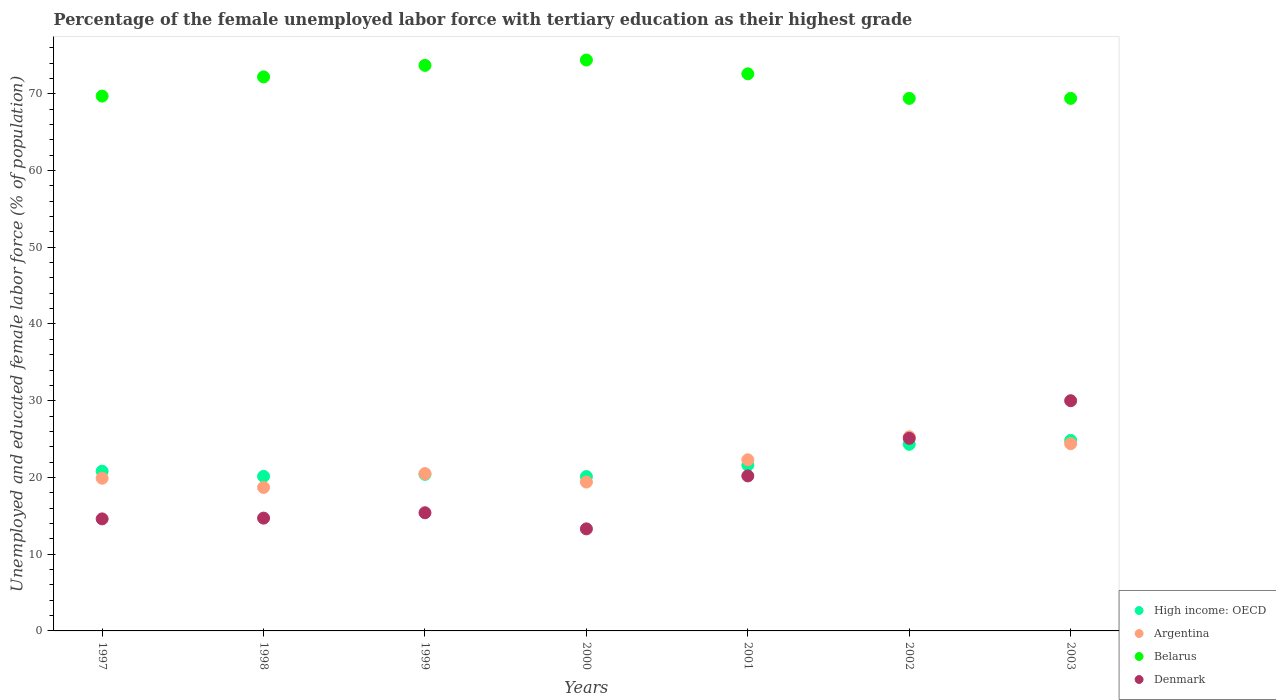How many different coloured dotlines are there?
Make the answer very short. 4. Is the number of dotlines equal to the number of legend labels?
Ensure brevity in your answer.  Yes. What is the percentage of the unemployed female labor force with tertiary education in Argentina in 2001?
Your answer should be compact. 22.3. Across all years, what is the maximum percentage of the unemployed female labor force with tertiary education in Argentina?
Offer a terse response. 25.3. Across all years, what is the minimum percentage of the unemployed female labor force with tertiary education in Argentina?
Ensure brevity in your answer.  18.7. In which year was the percentage of the unemployed female labor force with tertiary education in Belarus minimum?
Your answer should be very brief. 2002. What is the total percentage of the unemployed female labor force with tertiary education in High income: OECD in the graph?
Provide a short and direct response. 152.23. What is the difference between the percentage of the unemployed female labor force with tertiary education in Belarus in 1999 and that in 2002?
Provide a succinct answer. 4.3. What is the difference between the percentage of the unemployed female labor force with tertiary education in Argentina in 1997 and the percentage of the unemployed female labor force with tertiary education in High income: OECD in 1999?
Your answer should be compact. -0.51. What is the average percentage of the unemployed female labor force with tertiary education in Denmark per year?
Offer a terse response. 19.04. In the year 1998, what is the difference between the percentage of the unemployed female labor force with tertiary education in Belarus and percentage of the unemployed female labor force with tertiary education in Denmark?
Keep it short and to the point. 57.5. In how many years, is the percentage of the unemployed female labor force with tertiary education in High income: OECD greater than 40 %?
Your answer should be very brief. 0. What is the ratio of the percentage of the unemployed female labor force with tertiary education in Denmark in 1999 to that in 2000?
Your response must be concise. 1.16. Is the percentage of the unemployed female labor force with tertiary education in High income: OECD in 1998 less than that in 1999?
Your answer should be compact. Yes. Is the difference between the percentage of the unemployed female labor force with tertiary education in Belarus in 1997 and 2002 greater than the difference between the percentage of the unemployed female labor force with tertiary education in Denmark in 1997 and 2002?
Your answer should be very brief. Yes. What is the difference between the highest and the second highest percentage of the unemployed female labor force with tertiary education in Denmark?
Offer a terse response. 4.9. What is the difference between the highest and the lowest percentage of the unemployed female labor force with tertiary education in Belarus?
Give a very brief answer. 5. Is the sum of the percentage of the unemployed female labor force with tertiary education in Denmark in 2000 and 2003 greater than the maximum percentage of the unemployed female labor force with tertiary education in Argentina across all years?
Provide a succinct answer. Yes. Is it the case that in every year, the sum of the percentage of the unemployed female labor force with tertiary education in High income: OECD and percentage of the unemployed female labor force with tertiary education in Belarus  is greater than the sum of percentage of the unemployed female labor force with tertiary education in Argentina and percentage of the unemployed female labor force with tertiary education in Denmark?
Ensure brevity in your answer.  Yes. Is the percentage of the unemployed female labor force with tertiary education in Argentina strictly greater than the percentage of the unemployed female labor force with tertiary education in Denmark over the years?
Make the answer very short. No. Is the percentage of the unemployed female labor force with tertiary education in Belarus strictly less than the percentage of the unemployed female labor force with tertiary education in Denmark over the years?
Give a very brief answer. No. How many dotlines are there?
Provide a short and direct response. 4. How many years are there in the graph?
Give a very brief answer. 7. Does the graph contain grids?
Keep it short and to the point. No. Where does the legend appear in the graph?
Provide a short and direct response. Bottom right. How many legend labels are there?
Offer a terse response. 4. How are the legend labels stacked?
Make the answer very short. Vertical. What is the title of the graph?
Your answer should be compact. Percentage of the female unemployed labor force with tertiary education as their highest grade. What is the label or title of the X-axis?
Provide a short and direct response. Years. What is the label or title of the Y-axis?
Your response must be concise. Unemployed and educated female labor force (% of population). What is the Unemployed and educated female labor force (% of population) of High income: OECD in 1997?
Provide a short and direct response. 20.81. What is the Unemployed and educated female labor force (% of population) in Argentina in 1997?
Offer a terse response. 19.9. What is the Unemployed and educated female labor force (% of population) in Belarus in 1997?
Ensure brevity in your answer.  69.7. What is the Unemployed and educated female labor force (% of population) of Denmark in 1997?
Provide a short and direct response. 14.6. What is the Unemployed and educated female labor force (% of population) in High income: OECD in 1998?
Your answer should be compact. 20.14. What is the Unemployed and educated female labor force (% of population) in Argentina in 1998?
Give a very brief answer. 18.7. What is the Unemployed and educated female labor force (% of population) of Belarus in 1998?
Offer a very short reply. 72.2. What is the Unemployed and educated female labor force (% of population) in Denmark in 1998?
Ensure brevity in your answer.  14.7. What is the Unemployed and educated female labor force (% of population) in High income: OECD in 1999?
Offer a very short reply. 20.41. What is the Unemployed and educated female labor force (% of population) of Belarus in 1999?
Offer a terse response. 73.7. What is the Unemployed and educated female labor force (% of population) in Denmark in 1999?
Your answer should be compact. 15.4. What is the Unemployed and educated female labor force (% of population) in High income: OECD in 2000?
Offer a terse response. 20.12. What is the Unemployed and educated female labor force (% of population) of Argentina in 2000?
Provide a succinct answer. 19.4. What is the Unemployed and educated female labor force (% of population) in Belarus in 2000?
Offer a terse response. 74.4. What is the Unemployed and educated female labor force (% of population) of Denmark in 2000?
Provide a succinct answer. 13.3. What is the Unemployed and educated female labor force (% of population) in High income: OECD in 2001?
Provide a short and direct response. 21.6. What is the Unemployed and educated female labor force (% of population) in Argentina in 2001?
Provide a short and direct response. 22.3. What is the Unemployed and educated female labor force (% of population) in Belarus in 2001?
Give a very brief answer. 72.6. What is the Unemployed and educated female labor force (% of population) of Denmark in 2001?
Offer a terse response. 20.2. What is the Unemployed and educated female labor force (% of population) of High income: OECD in 2002?
Provide a short and direct response. 24.32. What is the Unemployed and educated female labor force (% of population) in Argentina in 2002?
Provide a short and direct response. 25.3. What is the Unemployed and educated female labor force (% of population) in Belarus in 2002?
Ensure brevity in your answer.  69.4. What is the Unemployed and educated female labor force (% of population) of Denmark in 2002?
Your answer should be very brief. 25.1. What is the Unemployed and educated female labor force (% of population) in High income: OECD in 2003?
Offer a very short reply. 24.83. What is the Unemployed and educated female labor force (% of population) of Argentina in 2003?
Ensure brevity in your answer.  24.4. What is the Unemployed and educated female labor force (% of population) of Belarus in 2003?
Make the answer very short. 69.4. What is the Unemployed and educated female labor force (% of population) in Denmark in 2003?
Provide a short and direct response. 30. Across all years, what is the maximum Unemployed and educated female labor force (% of population) in High income: OECD?
Your answer should be very brief. 24.83. Across all years, what is the maximum Unemployed and educated female labor force (% of population) in Argentina?
Offer a terse response. 25.3. Across all years, what is the maximum Unemployed and educated female labor force (% of population) of Belarus?
Make the answer very short. 74.4. Across all years, what is the maximum Unemployed and educated female labor force (% of population) of Denmark?
Offer a terse response. 30. Across all years, what is the minimum Unemployed and educated female labor force (% of population) in High income: OECD?
Your response must be concise. 20.12. Across all years, what is the minimum Unemployed and educated female labor force (% of population) in Argentina?
Your answer should be very brief. 18.7. Across all years, what is the minimum Unemployed and educated female labor force (% of population) in Belarus?
Provide a succinct answer. 69.4. Across all years, what is the minimum Unemployed and educated female labor force (% of population) in Denmark?
Your answer should be very brief. 13.3. What is the total Unemployed and educated female labor force (% of population) in High income: OECD in the graph?
Keep it short and to the point. 152.23. What is the total Unemployed and educated female labor force (% of population) in Argentina in the graph?
Make the answer very short. 150.5. What is the total Unemployed and educated female labor force (% of population) of Belarus in the graph?
Ensure brevity in your answer.  501.4. What is the total Unemployed and educated female labor force (% of population) of Denmark in the graph?
Make the answer very short. 133.3. What is the difference between the Unemployed and educated female labor force (% of population) in High income: OECD in 1997 and that in 1998?
Keep it short and to the point. 0.67. What is the difference between the Unemployed and educated female labor force (% of population) of Argentina in 1997 and that in 1998?
Offer a very short reply. 1.2. What is the difference between the Unemployed and educated female labor force (% of population) of High income: OECD in 1997 and that in 1999?
Offer a terse response. 0.4. What is the difference between the Unemployed and educated female labor force (% of population) in Argentina in 1997 and that in 1999?
Your response must be concise. -0.6. What is the difference between the Unemployed and educated female labor force (% of population) of Belarus in 1997 and that in 1999?
Make the answer very short. -4. What is the difference between the Unemployed and educated female labor force (% of population) in Denmark in 1997 and that in 1999?
Provide a succinct answer. -0.8. What is the difference between the Unemployed and educated female labor force (% of population) in High income: OECD in 1997 and that in 2000?
Keep it short and to the point. 0.7. What is the difference between the Unemployed and educated female labor force (% of population) in High income: OECD in 1997 and that in 2001?
Provide a short and direct response. -0.79. What is the difference between the Unemployed and educated female labor force (% of population) in High income: OECD in 1997 and that in 2002?
Make the answer very short. -3.51. What is the difference between the Unemployed and educated female labor force (% of population) of Argentina in 1997 and that in 2002?
Keep it short and to the point. -5.4. What is the difference between the Unemployed and educated female labor force (% of population) in High income: OECD in 1997 and that in 2003?
Offer a very short reply. -4.02. What is the difference between the Unemployed and educated female labor force (% of population) in Argentina in 1997 and that in 2003?
Provide a short and direct response. -4.5. What is the difference between the Unemployed and educated female labor force (% of population) in Belarus in 1997 and that in 2003?
Keep it short and to the point. 0.3. What is the difference between the Unemployed and educated female labor force (% of population) of Denmark in 1997 and that in 2003?
Keep it short and to the point. -15.4. What is the difference between the Unemployed and educated female labor force (% of population) of High income: OECD in 1998 and that in 1999?
Ensure brevity in your answer.  -0.27. What is the difference between the Unemployed and educated female labor force (% of population) in Argentina in 1998 and that in 1999?
Make the answer very short. -1.8. What is the difference between the Unemployed and educated female labor force (% of population) in High income: OECD in 1998 and that in 2000?
Your response must be concise. 0.03. What is the difference between the Unemployed and educated female labor force (% of population) of Argentina in 1998 and that in 2000?
Your response must be concise. -0.7. What is the difference between the Unemployed and educated female labor force (% of population) of Denmark in 1998 and that in 2000?
Provide a short and direct response. 1.4. What is the difference between the Unemployed and educated female labor force (% of population) of High income: OECD in 1998 and that in 2001?
Make the answer very short. -1.46. What is the difference between the Unemployed and educated female labor force (% of population) of Argentina in 1998 and that in 2001?
Offer a very short reply. -3.6. What is the difference between the Unemployed and educated female labor force (% of population) in Belarus in 1998 and that in 2001?
Your answer should be very brief. -0.4. What is the difference between the Unemployed and educated female labor force (% of population) in Denmark in 1998 and that in 2001?
Make the answer very short. -5.5. What is the difference between the Unemployed and educated female labor force (% of population) of High income: OECD in 1998 and that in 2002?
Offer a terse response. -4.17. What is the difference between the Unemployed and educated female labor force (% of population) in Argentina in 1998 and that in 2002?
Keep it short and to the point. -6.6. What is the difference between the Unemployed and educated female labor force (% of population) in Belarus in 1998 and that in 2002?
Offer a very short reply. 2.8. What is the difference between the Unemployed and educated female labor force (% of population) of Denmark in 1998 and that in 2002?
Your answer should be very brief. -10.4. What is the difference between the Unemployed and educated female labor force (% of population) in High income: OECD in 1998 and that in 2003?
Your answer should be compact. -4.69. What is the difference between the Unemployed and educated female labor force (% of population) of Denmark in 1998 and that in 2003?
Give a very brief answer. -15.3. What is the difference between the Unemployed and educated female labor force (% of population) of High income: OECD in 1999 and that in 2000?
Your answer should be compact. 0.29. What is the difference between the Unemployed and educated female labor force (% of population) in Belarus in 1999 and that in 2000?
Offer a terse response. -0.7. What is the difference between the Unemployed and educated female labor force (% of population) of High income: OECD in 1999 and that in 2001?
Provide a short and direct response. -1.19. What is the difference between the Unemployed and educated female labor force (% of population) in Argentina in 1999 and that in 2001?
Offer a very short reply. -1.8. What is the difference between the Unemployed and educated female labor force (% of population) in Belarus in 1999 and that in 2001?
Your answer should be very brief. 1.1. What is the difference between the Unemployed and educated female labor force (% of population) in High income: OECD in 1999 and that in 2002?
Provide a succinct answer. -3.91. What is the difference between the Unemployed and educated female labor force (% of population) of Belarus in 1999 and that in 2002?
Ensure brevity in your answer.  4.3. What is the difference between the Unemployed and educated female labor force (% of population) in High income: OECD in 1999 and that in 2003?
Make the answer very short. -4.42. What is the difference between the Unemployed and educated female labor force (% of population) of Denmark in 1999 and that in 2003?
Provide a short and direct response. -14.6. What is the difference between the Unemployed and educated female labor force (% of population) of High income: OECD in 2000 and that in 2001?
Make the answer very short. -1.48. What is the difference between the Unemployed and educated female labor force (% of population) of Belarus in 2000 and that in 2001?
Provide a short and direct response. 1.8. What is the difference between the Unemployed and educated female labor force (% of population) of High income: OECD in 2000 and that in 2002?
Offer a very short reply. -4.2. What is the difference between the Unemployed and educated female labor force (% of population) in Denmark in 2000 and that in 2002?
Make the answer very short. -11.8. What is the difference between the Unemployed and educated female labor force (% of population) of High income: OECD in 2000 and that in 2003?
Provide a short and direct response. -4.71. What is the difference between the Unemployed and educated female labor force (% of population) of Denmark in 2000 and that in 2003?
Ensure brevity in your answer.  -16.7. What is the difference between the Unemployed and educated female labor force (% of population) in High income: OECD in 2001 and that in 2002?
Make the answer very short. -2.72. What is the difference between the Unemployed and educated female labor force (% of population) in High income: OECD in 2001 and that in 2003?
Provide a short and direct response. -3.23. What is the difference between the Unemployed and educated female labor force (% of population) in Argentina in 2001 and that in 2003?
Make the answer very short. -2.1. What is the difference between the Unemployed and educated female labor force (% of population) in Belarus in 2001 and that in 2003?
Your answer should be very brief. 3.2. What is the difference between the Unemployed and educated female labor force (% of population) of Denmark in 2001 and that in 2003?
Keep it short and to the point. -9.8. What is the difference between the Unemployed and educated female labor force (% of population) in High income: OECD in 2002 and that in 2003?
Ensure brevity in your answer.  -0.51. What is the difference between the Unemployed and educated female labor force (% of population) in Belarus in 2002 and that in 2003?
Give a very brief answer. 0. What is the difference between the Unemployed and educated female labor force (% of population) in High income: OECD in 1997 and the Unemployed and educated female labor force (% of population) in Argentina in 1998?
Your response must be concise. 2.11. What is the difference between the Unemployed and educated female labor force (% of population) of High income: OECD in 1997 and the Unemployed and educated female labor force (% of population) of Belarus in 1998?
Provide a succinct answer. -51.39. What is the difference between the Unemployed and educated female labor force (% of population) in High income: OECD in 1997 and the Unemployed and educated female labor force (% of population) in Denmark in 1998?
Provide a succinct answer. 6.11. What is the difference between the Unemployed and educated female labor force (% of population) of Argentina in 1997 and the Unemployed and educated female labor force (% of population) of Belarus in 1998?
Keep it short and to the point. -52.3. What is the difference between the Unemployed and educated female labor force (% of population) of Argentina in 1997 and the Unemployed and educated female labor force (% of population) of Denmark in 1998?
Ensure brevity in your answer.  5.2. What is the difference between the Unemployed and educated female labor force (% of population) of Belarus in 1997 and the Unemployed and educated female labor force (% of population) of Denmark in 1998?
Provide a short and direct response. 55. What is the difference between the Unemployed and educated female labor force (% of population) of High income: OECD in 1997 and the Unemployed and educated female labor force (% of population) of Argentina in 1999?
Make the answer very short. 0.31. What is the difference between the Unemployed and educated female labor force (% of population) in High income: OECD in 1997 and the Unemployed and educated female labor force (% of population) in Belarus in 1999?
Keep it short and to the point. -52.89. What is the difference between the Unemployed and educated female labor force (% of population) in High income: OECD in 1997 and the Unemployed and educated female labor force (% of population) in Denmark in 1999?
Keep it short and to the point. 5.41. What is the difference between the Unemployed and educated female labor force (% of population) in Argentina in 1997 and the Unemployed and educated female labor force (% of population) in Belarus in 1999?
Your answer should be very brief. -53.8. What is the difference between the Unemployed and educated female labor force (% of population) in Argentina in 1997 and the Unemployed and educated female labor force (% of population) in Denmark in 1999?
Offer a terse response. 4.5. What is the difference between the Unemployed and educated female labor force (% of population) of Belarus in 1997 and the Unemployed and educated female labor force (% of population) of Denmark in 1999?
Make the answer very short. 54.3. What is the difference between the Unemployed and educated female labor force (% of population) in High income: OECD in 1997 and the Unemployed and educated female labor force (% of population) in Argentina in 2000?
Make the answer very short. 1.41. What is the difference between the Unemployed and educated female labor force (% of population) of High income: OECD in 1997 and the Unemployed and educated female labor force (% of population) of Belarus in 2000?
Make the answer very short. -53.59. What is the difference between the Unemployed and educated female labor force (% of population) of High income: OECD in 1997 and the Unemployed and educated female labor force (% of population) of Denmark in 2000?
Keep it short and to the point. 7.51. What is the difference between the Unemployed and educated female labor force (% of population) of Argentina in 1997 and the Unemployed and educated female labor force (% of population) of Belarus in 2000?
Give a very brief answer. -54.5. What is the difference between the Unemployed and educated female labor force (% of population) of Belarus in 1997 and the Unemployed and educated female labor force (% of population) of Denmark in 2000?
Provide a short and direct response. 56.4. What is the difference between the Unemployed and educated female labor force (% of population) in High income: OECD in 1997 and the Unemployed and educated female labor force (% of population) in Argentina in 2001?
Your answer should be compact. -1.49. What is the difference between the Unemployed and educated female labor force (% of population) in High income: OECD in 1997 and the Unemployed and educated female labor force (% of population) in Belarus in 2001?
Your answer should be compact. -51.79. What is the difference between the Unemployed and educated female labor force (% of population) in High income: OECD in 1997 and the Unemployed and educated female labor force (% of population) in Denmark in 2001?
Make the answer very short. 0.61. What is the difference between the Unemployed and educated female labor force (% of population) in Argentina in 1997 and the Unemployed and educated female labor force (% of population) in Belarus in 2001?
Your response must be concise. -52.7. What is the difference between the Unemployed and educated female labor force (% of population) in Argentina in 1997 and the Unemployed and educated female labor force (% of population) in Denmark in 2001?
Give a very brief answer. -0.3. What is the difference between the Unemployed and educated female labor force (% of population) of Belarus in 1997 and the Unemployed and educated female labor force (% of population) of Denmark in 2001?
Your response must be concise. 49.5. What is the difference between the Unemployed and educated female labor force (% of population) of High income: OECD in 1997 and the Unemployed and educated female labor force (% of population) of Argentina in 2002?
Give a very brief answer. -4.49. What is the difference between the Unemployed and educated female labor force (% of population) of High income: OECD in 1997 and the Unemployed and educated female labor force (% of population) of Belarus in 2002?
Your answer should be very brief. -48.59. What is the difference between the Unemployed and educated female labor force (% of population) of High income: OECD in 1997 and the Unemployed and educated female labor force (% of population) of Denmark in 2002?
Your answer should be compact. -4.29. What is the difference between the Unemployed and educated female labor force (% of population) of Argentina in 1997 and the Unemployed and educated female labor force (% of population) of Belarus in 2002?
Keep it short and to the point. -49.5. What is the difference between the Unemployed and educated female labor force (% of population) in Argentina in 1997 and the Unemployed and educated female labor force (% of population) in Denmark in 2002?
Offer a very short reply. -5.2. What is the difference between the Unemployed and educated female labor force (% of population) in Belarus in 1997 and the Unemployed and educated female labor force (% of population) in Denmark in 2002?
Make the answer very short. 44.6. What is the difference between the Unemployed and educated female labor force (% of population) of High income: OECD in 1997 and the Unemployed and educated female labor force (% of population) of Argentina in 2003?
Ensure brevity in your answer.  -3.59. What is the difference between the Unemployed and educated female labor force (% of population) in High income: OECD in 1997 and the Unemployed and educated female labor force (% of population) in Belarus in 2003?
Give a very brief answer. -48.59. What is the difference between the Unemployed and educated female labor force (% of population) of High income: OECD in 1997 and the Unemployed and educated female labor force (% of population) of Denmark in 2003?
Give a very brief answer. -9.19. What is the difference between the Unemployed and educated female labor force (% of population) of Argentina in 1997 and the Unemployed and educated female labor force (% of population) of Belarus in 2003?
Provide a succinct answer. -49.5. What is the difference between the Unemployed and educated female labor force (% of population) of Argentina in 1997 and the Unemployed and educated female labor force (% of population) of Denmark in 2003?
Offer a terse response. -10.1. What is the difference between the Unemployed and educated female labor force (% of population) in Belarus in 1997 and the Unemployed and educated female labor force (% of population) in Denmark in 2003?
Offer a terse response. 39.7. What is the difference between the Unemployed and educated female labor force (% of population) of High income: OECD in 1998 and the Unemployed and educated female labor force (% of population) of Argentina in 1999?
Provide a short and direct response. -0.36. What is the difference between the Unemployed and educated female labor force (% of population) in High income: OECD in 1998 and the Unemployed and educated female labor force (% of population) in Belarus in 1999?
Give a very brief answer. -53.56. What is the difference between the Unemployed and educated female labor force (% of population) in High income: OECD in 1998 and the Unemployed and educated female labor force (% of population) in Denmark in 1999?
Offer a very short reply. 4.74. What is the difference between the Unemployed and educated female labor force (% of population) in Argentina in 1998 and the Unemployed and educated female labor force (% of population) in Belarus in 1999?
Your answer should be compact. -55. What is the difference between the Unemployed and educated female labor force (% of population) in Belarus in 1998 and the Unemployed and educated female labor force (% of population) in Denmark in 1999?
Your answer should be compact. 56.8. What is the difference between the Unemployed and educated female labor force (% of population) of High income: OECD in 1998 and the Unemployed and educated female labor force (% of population) of Argentina in 2000?
Make the answer very short. 0.74. What is the difference between the Unemployed and educated female labor force (% of population) in High income: OECD in 1998 and the Unemployed and educated female labor force (% of population) in Belarus in 2000?
Offer a very short reply. -54.26. What is the difference between the Unemployed and educated female labor force (% of population) in High income: OECD in 1998 and the Unemployed and educated female labor force (% of population) in Denmark in 2000?
Provide a short and direct response. 6.84. What is the difference between the Unemployed and educated female labor force (% of population) in Argentina in 1998 and the Unemployed and educated female labor force (% of population) in Belarus in 2000?
Make the answer very short. -55.7. What is the difference between the Unemployed and educated female labor force (% of population) of Belarus in 1998 and the Unemployed and educated female labor force (% of population) of Denmark in 2000?
Your answer should be compact. 58.9. What is the difference between the Unemployed and educated female labor force (% of population) in High income: OECD in 1998 and the Unemployed and educated female labor force (% of population) in Argentina in 2001?
Keep it short and to the point. -2.16. What is the difference between the Unemployed and educated female labor force (% of population) of High income: OECD in 1998 and the Unemployed and educated female labor force (% of population) of Belarus in 2001?
Your answer should be compact. -52.46. What is the difference between the Unemployed and educated female labor force (% of population) of High income: OECD in 1998 and the Unemployed and educated female labor force (% of population) of Denmark in 2001?
Offer a terse response. -0.06. What is the difference between the Unemployed and educated female labor force (% of population) of Argentina in 1998 and the Unemployed and educated female labor force (% of population) of Belarus in 2001?
Ensure brevity in your answer.  -53.9. What is the difference between the Unemployed and educated female labor force (% of population) in Belarus in 1998 and the Unemployed and educated female labor force (% of population) in Denmark in 2001?
Ensure brevity in your answer.  52. What is the difference between the Unemployed and educated female labor force (% of population) in High income: OECD in 1998 and the Unemployed and educated female labor force (% of population) in Argentina in 2002?
Make the answer very short. -5.16. What is the difference between the Unemployed and educated female labor force (% of population) in High income: OECD in 1998 and the Unemployed and educated female labor force (% of population) in Belarus in 2002?
Ensure brevity in your answer.  -49.26. What is the difference between the Unemployed and educated female labor force (% of population) in High income: OECD in 1998 and the Unemployed and educated female labor force (% of population) in Denmark in 2002?
Keep it short and to the point. -4.96. What is the difference between the Unemployed and educated female labor force (% of population) of Argentina in 1998 and the Unemployed and educated female labor force (% of population) of Belarus in 2002?
Keep it short and to the point. -50.7. What is the difference between the Unemployed and educated female labor force (% of population) of Belarus in 1998 and the Unemployed and educated female labor force (% of population) of Denmark in 2002?
Offer a very short reply. 47.1. What is the difference between the Unemployed and educated female labor force (% of population) of High income: OECD in 1998 and the Unemployed and educated female labor force (% of population) of Argentina in 2003?
Your answer should be compact. -4.26. What is the difference between the Unemployed and educated female labor force (% of population) of High income: OECD in 1998 and the Unemployed and educated female labor force (% of population) of Belarus in 2003?
Give a very brief answer. -49.26. What is the difference between the Unemployed and educated female labor force (% of population) of High income: OECD in 1998 and the Unemployed and educated female labor force (% of population) of Denmark in 2003?
Ensure brevity in your answer.  -9.86. What is the difference between the Unemployed and educated female labor force (% of population) in Argentina in 1998 and the Unemployed and educated female labor force (% of population) in Belarus in 2003?
Make the answer very short. -50.7. What is the difference between the Unemployed and educated female labor force (% of population) in Argentina in 1998 and the Unemployed and educated female labor force (% of population) in Denmark in 2003?
Ensure brevity in your answer.  -11.3. What is the difference between the Unemployed and educated female labor force (% of population) in Belarus in 1998 and the Unemployed and educated female labor force (% of population) in Denmark in 2003?
Make the answer very short. 42.2. What is the difference between the Unemployed and educated female labor force (% of population) in High income: OECD in 1999 and the Unemployed and educated female labor force (% of population) in Argentina in 2000?
Provide a succinct answer. 1.01. What is the difference between the Unemployed and educated female labor force (% of population) in High income: OECD in 1999 and the Unemployed and educated female labor force (% of population) in Belarus in 2000?
Offer a very short reply. -53.99. What is the difference between the Unemployed and educated female labor force (% of population) in High income: OECD in 1999 and the Unemployed and educated female labor force (% of population) in Denmark in 2000?
Your answer should be compact. 7.11. What is the difference between the Unemployed and educated female labor force (% of population) of Argentina in 1999 and the Unemployed and educated female labor force (% of population) of Belarus in 2000?
Offer a terse response. -53.9. What is the difference between the Unemployed and educated female labor force (% of population) in Belarus in 1999 and the Unemployed and educated female labor force (% of population) in Denmark in 2000?
Keep it short and to the point. 60.4. What is the difference between the Unemployed and educated female labor force (% of population) of High income: OECD in 1999 and the Unemployed and educated female labor force (% of population) of Argentina in 2001?
Your answer should be very brief. -1.89. What is the difference between the Unemployed and educated female labor force (% of population) in High income: OECD in 1999 and the Unemployed and educated female labor force (% of population) in Belarus in 2001?
Ensure brevity in your answer.  -52.19. What is the difference between the Unemployed and educated female labor force (% of population) of High income: OECD in 1999 and the Unemployed and educated female labor force (% of population) of Denmark in 2001?
Keep it short and to the point. 0.21. What is the difference between the Unemployed and educated female labor force (% of population) in Argentina in 1999 and the Unemployed and educated female labor force (% of population) in Belarus in 2001?
Provide a short and direct response. -52.1. What is the difference between the Unemployed and educated female labor force (% of population) of Belarus in 1999 and the Unemployed and educated female labor force (% of population) of Denmark in 2001?
Your answer should be compact. 53.5. What is the difference between the Unemployed and educated female labor force (% of population) in High income: OECD in 1999 and the Unemployed and educated female labor force (% of population) in Argentina in 2002?
Ensure brevity in your answer.  -4.89. What is the difference between the Unemployed and educated female labor force (% of population) of High income: OECD in 1999 and the Unemployed and educated female labor force (% of population) of Belarus in 2002?
Your answer should be very brief. -48.99. What is the difference between the Unemployed and educated female labor force (% of population) of High income: OECD in 1999 and the Unemployed and educated female labor force (% of population) of Denmark in 2002?
Keep it short and to the point. -4.69. What is the difference between the Unemployed and educated female labor force (% of population) in Argentina in 1999 and the Unemployed and educated female labor force (% of population) in Belarus in 2002?
Ensure brevity in your answer.  -48.9. What is the difference between the Unemployed and educated female labor force (% of population) of Argentina in 1999 and the Unemployed and educated female labor force (% of population) of Denmark in 2002?
Your answer should be very brief. -4.6. What is the difference between the Unemployed and educated female labor force (% of population) in Belarus in 1999 and the Unemployed and educated female labor force (% of population) in Denmark in 2002?
Give a very brief answer. 48.6. What is the difference between the Unemployed and educated female labor force (% of population) in High income: OECD in 1999 and the Unemployed and educated female labor force (% of population) in Argentina in 2003?
Make the answer very short. -3.99. What is the difference between the Unemployed and educated female labor force (% of population) in High income: OECD in 1999 and the Unemployed and educated female labor force (% of population) in Belarus in 2003?
Offer a terse response. -48.99. What is the difference between the Unemployed and educated female labor force (% of population) in High income: OECD in 1999 and the Unemployed and educated female labor force (% of population) in Denmark in 2003?
Your answer should be very brief. -9.59. What is the difference between the Unemployed and educated female labor force (% of population) of Argentina in 1999 and the Unemployed and educated female labor force (% of population) of Belarus in 2003?
Provide a succinct answer. -48.9. What is the difference between the Unemployed and educated female labor force (% of population) of Belarus in 1999 and the Unemployed and educated female labor force (% of population) of Denmark in 2003?
Ensure brevity in your answer.  43.7. What is the difference between the Unemployed and educated female labor force (% of population) in High income: OECD in 2000 and the Unemployed and educated female labor force (% of population) in Argentina in 2001?
Ensure brevity in your answer.  -2.18. What is the difference between the Unemployed and educated female labor force (% of population) of High income: OECD in 2000 and the Unemployed and educated female labor force (% of population) of Belarus in 2001?
Offer a very short reply. -52.48. What is the difference between the Unemployed and educated female labor force (% of population) of High income: OECD in 2000 and the Unemployed and educated female labor force (% of population) of Denmark in 2001?
Give a very brief answer. -0.08. What is the difference between the Unemployed and educated female labor force (% of population) of Argentina in 2000 and the Unemployed and educated female labor force (% of population) of Belarus in 2001?
Offer a terse response. -53.2. What is the difference between the Unemployed and educated female labor force (% of population) of Argentina in 2000 and the Unemployed and educated female labor force (% of population) of Denmark in 2001?
Give a very brief answer. -0.8. What is the difference between the Unemployed and educated female labor force (% of population) of Belarus in 2000 and the Unemployed and educated female labor force (% of population) of Denmark in 2001?
Your answer should be compact. 54.2. What is the difference between the Unemployed and educated female labor force (% of population) in High income: OECD in 2000 and the Unemployed and educated female labor force (% of population) in Argentina in 2002?
Give a very brief answer. -5.18. What is the difference between the Unemployed and educated female labor force (% of population) of High income: OECD in 2000 and the Unemployed and educated female labor force (% of population) of Belarus in 2002?
Your answer should be very brief. -49.28. What is the difference between the Unemployed and educated female labor force (% of population) in High income: OECD in 2000 and the Unemployed and educated female labor force (% of population) in Denmark in 2002?
Offer a very short reply. -4.98. What is the difference between the Unemployed and educated female labor force (% of population) in Belarus in 2000 and the Unemployed and educated female labor force (% of population) in Denmark in 2002?
Your response must be concise. 49.3. What is the difference between the Unemployed and educated female labor force (% of population) of High income: OECD in 2000 and the Unemployed and educated female labor force (% of population) of Argentina in 2003?
Keep it short and to the point. -4.28. What is the difference between the Unemployed and educated female labor force (% of population) in High income: OECD in 2000 and the Unemployed and educated female labor force (% of population) in Belarus in 2003?
Keep it short and to the point. -49.28. What is the difference between the Unemployed and educated female labor force (% of population) in High income: OECD in 2000 and the Unemployed and educated female labor force (% of population) in Denmark in 2003?
Offer a terse response. -9.88. What is the difference between the Unemployed and educated female labor force (% of population) of Belarus in 2000 and the Unemployed and educated female labor force (% of population) of Denmark in 2003?
Make the answer very short. 44.4. What is the difference between the Unemployed and educated female labor force (% of population) of High income: OECD in 2001 and the Unemployed and educated female labor force (% of population) of Argentina in 2002?
Ensure brevity in your answer.  -3.7. What is the difference between the Unemployed and educated female labor force (% of population) in High income: OECD in 2001 and the Unemployed and educated female labor force (% of population) in Belarus in 2002?
Offer a terse response. -47.8. What is the difference between the Unemployed and educated female labor force (% of population) in High income: OECD in 2001 and the Unemployed and educated female labor force (% of population) in Denmark in 2002?
Your response must be concise. -3.5. What is the difference between the Unemployed and educated female labor force (% of population) in Argentina in 2001 and the Unemployed and educated female labor force (% of population) in Belarus in 2002?
Your response must be concise. -47.1. What is the difference between the Unemployed and educated female labor force (% of population) in Belarus in 2001 and the Unemployed and educated female labor force (% of population) in Denmark in 2002?
Your response must be concise. 47.5. What is the difference between the Unemployed and educated female labor force (% of population) in High income: OECD in 2001 and the Unemployed and educated female labor force (% of population) in Argentina in 2003?
Your answer should be compact. -2.8. What is the difference between the Unemployed and educated female labor force (% of population) in High income: OECD in 2001 and the Unemployed and educated female labor force (% of population) in Belarus in 2003?
Offer a terse response. -47.8. What is the difference between the Unemployed and educated female labor force (% of population) of High income: OECD in 2001 and the Unemployed and educated female labor force (% of population) of Denmark in 2003?
Provide a short and direct response. -8.4. What is the difference between the Unemployed and educated female labor force (% of population) in Argentina in 2001 and the Unemployed and educated female labor force (% of population) in Belarus in 2003?
Your answer should be very brief. -47.1. What is the difference between the Unemployed and educated female labor force (% of population) of Argentina in 2001 and the Unemployed and educated female labor force (% of population) of Denmark in 2003?
Offer a very short reply. -7.7. What is the difference between the Unemployed and educated female labor force (% of population) of Belarus in 2001 and the Unemployed and educated female labor force (% of population) of Denmark in 2003?
Keep it short and to the point. 42.6. What is the difference between the Unemployed and educated female labor force (% of population) in High income: OECD in 2002 and the Unemployed and educated female labor force (% of population) in Argentina in 2003?
Offer a very short reply. -0.08. What is the difference between the Unemployed and educated female labor force (% of population) in High income: OECD in 2002 and the Unemployed and educated female labor force (% of population) in Belarus in 2003?
Your answer should be very brief. -45.08. What is the difference between the Unemployed and educated female labor force (% of population) in High income: OECD in 2002 and the Unemployed and educated female labor force (% of population) in Denmark in 2003?
Give a very brief answer. -5.68. What is the difference between the Unemployed and educated female labor force (% of population) in Argentina in 2002 and the Unemployed and educated female labor force (% of population) in Belarus in 2003?
Give a very brief answer. -44.1. What is the difference between the Unemployed and educated female labor force (% of population) of Belarus in 2002 and the Unemployed and educated female labor force (% of population) of Denmark in 2003?
Make the answer very short. 39.4. What is the average Unemployed and educated female labor force (% of population) in High income: OECD per year?
Offer a very short reply. 21.75. What is the average Unemployed and educated female labor force (% of population) in Argentina per year?
Your answer should be compact. 21.5. What is the average Unemployed and educated female labor force (% of population) of Belarus per year?
Offer a terse response. 71.63. What is the average Unemployed and educated female labor force (% of population) in Denmark per year?
Give a very brief answer. 19.04. In the year 1997, what is the difference between the Unemployed and educated female labor force (% of population) of High income: OECD and Unemployed and educated female labor force (% of population) of Argentina?
Make the answer very short. 0.91. In the year 1997, what is the difference between the Unemployed and educated female labor force (% of population) in High income: OECD and Unemployed and educated female labor force (% of population) in Belarus?
Offer a very short reply. -48.89. In the year 1997, what is the difference between the Unemployed and educated female labor force (% of population) of High income: OECD and Unemployed and educated female labor force (% of population) of Denmark?
Offer a very short reply. 6.21. In the year 1997, what is the difference between the Unemployed and educated female labor force (% of population) of Argentina and Unemployed and educated female labor force (% of population) of Belarus?
Ensure brevity in your answer.  -49.8. In the year 1997, what is the difference between the Unemployed and educated female labor force (% of population) of Argentina and Unemployed and educated female labor force (% of population) of Denmark?
Provide a short and direct response. 5.3. In the year 1997, what is the difference between the Unemployed and educated female labor force (% of population) in Belarus and Unemployed and educated female labor force (% of population) in Denmark?
Provide a short and direct response. 55.1. In the year 1998, what is the difference between the Unemployed and educated female labor force (% of population) in High income: OECD and Unemployed and educated female labor force (% of population) in Argentina?
Keep it short and to the point. 1.44. In the year 1998, what is the difference between the Unemployed and educated female labor force (% of population) of High income: OECD and Unemployed and educated female labor force (% of population) of Belarus?
Your answer should be compact. -52.06. In the year 1998, what is the difference between the Unemployed and educated female labor force (% of population) in High income: OECD and Unemployed and educated female labor force (% of population) in Denmark?
Ensure brevity in your answer.  5.44. In the year 1998, what is the difference between the Unemployed and educated female labor force (% of population) in Argentina and Unemployed and educated female labor force (% of population) in Belarus?
Offer a very short reply. -53.5. In the year 1998, what is the difference between the Unemployed and educated female labor force (% of population) in Belarus and Unemployed and educated female labor force (% of population) in Denmark?
Give a very brief answer. 57.5. In the year 1999, what is the difference between the Unemployed and educated female labor force (% of population) of High income: OECD and Unemployed and educated female labor force (% of population) of Argentina?
Provide a succinct answer. -0.09. In the year 1999, what is the difference between the Unemployed and educated female labor force (% of population) of High income: OECD and Unemployed and educated female labor force (% of population) of Belarus?
Give a very brief answer. -53.29. In the year 1999, what is the difference between the Unemployed and educated female labor force (% of population) in High income: OECD and Unemployed and educated female labor force (% of population) in Denmark?
Offer a very short reply. 5.01. In the year 1999, what is the difference between the Unemployed and educated female labor force (% of population) of Argentina and Unemployed and educated female labor force (% of population) of Belarus?
Make the answer very short. -53.2. In the year 1999, what is the difference between the Unemployed and educated female labor force (% of population) in Belarus and Unemployed and educated female labor force (% of population) in Denmark?
Offer a very short reply. 58.3. In the year 2000, what is the difference between the Unemployed and educated female labor force (% of population) in High income: OECD and Unemployed and educated female labor force (% of population) in Argentina?
Provide a succinct answer. 0.72. In the year 2000, what is the difference between the Unemployed and educated female labor force (% of population) of High income: OECD and Unemployed and educated female labor force (% of population) of Belarus?
Provide a short and direct response. -54.28. In the year 2000, what is the difference between the Unemployed and educated female labor force (% of population) of High income: OECD and Unemployed and educated female labor force (% of population) of Denmark?
Your response must be concise. 6.82. In the year 2000, what is the difference between the Unemployed and educated female labor force (% of population) in Argentina and Unemployed and educated female labor force (% of population) in Belarus?
Ensure brevity in your answer.  -55. In the year 2000, what is the difference between the Unemployed and educated female labor force (% of population) in Argentina and Unemployed and educated female labor force (% of population) in Denmark?
Keep it short and to the point. 6.1. In the year 2000, what is the difference between the Unemployed and educated female labor force (% of population) of Belarus and Unemployed and educated female labor force (% of population) of Denmark?
Your answer should be compact. 61.1. In the year 2001, what is the difference between the Unemployed and educated female labor force (% of population) in High income: OECD and Unemployed and educated female labor force (% of population) in Argentina?
Make the answer very short. -0.7. In the year 2001, what is the difference between the Unemployed and educated female labor force (% of population) in High income: OECD and Unemployed and educated female labor force (% of population) in Belarus?
Your response must be concise. -51. In the year 2001, what is the difference between the Unemployed and educated female labor force (% of population) of High income: OECD and Unemployed and educated female labor force (% of population) of Denmark?
Offer a very short reply. 1.4. In the year 2001, what is the difference between the Unemployed and educated female labor force (% of population) of Argentina and Unemployed and educated female labor force (% of population) of Belarus?
Provide a short and direct response. -50.3. In the year 2001, what is the difference between the Unemployed and educated female labor force (% of population) of Argentina and Unemployed and educated female labor force (% of population) of Denmark?
Provide a succinct answer. 2.1. In the year 2001, what is the difference between the Unemployed and educated female labor force (% of population) of Belarus and Unemployed and educated female labor force (% of population) of Denmark?
Your answer should be compact. 52.4. In the year 2002, what is the difference between the Unemployed and educated female labor force (% of population) in High income: OECD and Unemployed and educated female labor force (% of population) in Argentina?
Give a very brief answer. -0.98. In the year 2002, what is the difference between the Unemployed and educated female labor force (% of population) of High income: OECD and Unemployed and educated female labor force (% of population) of Belarus?
Ensure brevity in your answer.  -45.08. In the year 2002, what is the difference between the Unemployed and educated female labor force (% of population) of High income: OECD and Unemployed and educated female labor force (% of population) of Denmark?
Provide a succinct answer. -0.78. In the year 2002, what is the difference between the Unemployed and educated female labor force (% of population) in Argentina and Unemployed and educated female labor force (% of population) in Belarus?
Provide a short and direct response. -44.1. In the year 2002, what is the difference between the Unemployed and educated female labor force (% of population) in Belarus and Unemployed and educated female labor force (% of population) in Denmark?
Ensure brevity in your answer.  44.3. In the year 2003, what is the difference between the Unemployed and educated female labor force (% of population) in High income: OECD and Unemployed and educated female labor force (% of population) in Argentina?
Your response must be concise. 0.43. In the year 2003, what is the difference between the Unemployed and educated female labor force (% of population) of High income: OECD and Unemployed and educated female labor force (% of population) of Belarus?
Your answer should be very brief. -44.57. In the year 2003, what is the difference between the Unemployed and educated female labor force (% of population) in High income: OECD and Unemployed and educated female labor force (% of population) in Denmark?
Your answer should be very brief. -5.17. In the year 2003, what is the difference between the Unemployed and educated female labor force (% of population) in Argentina and Unemployed and educated female labor force (% of population) in Belarus?
Provide a short and direct response. -45. In the year 2003, what is the difference between the Unemployed and educated female labor force (% of population) in Argentina and Unemployed and educated female labor force (% of population) in Denmark?
Your answer should be compact. -5.6. In the year 2003, what is the difference between the Unemployed and educated female labor force (% of population) in Belarus and Unemployed and educated female labor force (% of population) in Denmark?
Keep it short and to the point. 39.4. What is the ratio of the Unemployed and educated female labor force (% of population) of High income: OECD in 1997 to that in 1998?
Your response must be concise. 1.03. What is the ratio of the Unemployed and educated female labor force (% of population) of Argentina in 1997 to that in 1998?
Make the answer very short. 1.06. What is the ratio of the Unemployed and educated female labor force (% of population) in Belarus in 1997 to that in 1998?
Keep it short and to the point. 0.97. What is the ratio of the Unemployed and educated female labor force (% of population) of High income: OECD in 1997 to that in 1999?
Your answer should be compact. 1.02. What is the ratio of the Unemployed and educated female labor force (% of population) in Argentina in 1997 to that in 1999?
Your answer should be very brief. 0.97. What is the ratio of the Unemployed and educated female labor force (% of population) of Belarus in 1997 to that in 1999?
Your answer should be compact. 0.95. What is the ratio of the Unemployed and educated female labor force (% of population) in Denmark in 1997 to that in 1999?
Offer a terse response. 0.95. What is the ratio of the Unemployed and educated female labor force (% of population) in High income: OECD in 1997 to that in 2000?
Make the answer very short. 1.03. What is the ratio of the Unemployed and educated female labor force (% of population) in Argentina in 1997 to that in 2000?
Your answer should be compact. 1.03. What is the ratio of the Unemployed and educated female labor force (% of population) in Belarus in 1997 to that in 2000?
Your answer should be very brief. 0.94. What is the ratio of the Unemployed and educated female labor force (% of population) of Denmark in 1997 to that in 2000?
Make the answer very short. 1.1. What is the ratio of the Unemployed and educated female labor force (% of population) in High income: OECD in 1997 to that in 2001?
Make the answer very short. 0.96. What is the ratio of the Unemployed and educated female labor force (% of population) of Argentina in 1997 to that in 2001?
Your response must be concise. 0.89. What is the ratio of the Unemployed and educated female labor force (% of population) in Belarus in 1997 to that in 2001?
Your response must be concise. 0.96. What is the ratio of the Unemployed and educated female labor force (% of population) of Denmark in 1997 to that in 2001?
Make the answer very short. 0.72. What is the ratio of the Unemployed and educated female labor force (% of population) of High income: OECD in 1997 to that in 2002?
Your answer should be compact. 0.86. What is the ratio of the Unemployed and educated female labor force (% of population) in Argentina in 1997 to that in 2002?
Keep it short and to the point. 0.79. What is the ratio of the Unemployed and educated female labor force (% of population) in Belarus in 1997 to that in 2002?
Provide a short and direct response. 1. What is the ratio of the Unemployed and educated female labor force (% of population) in Denmark in 1997 to that in 2002?
Provide a succinct answer. 0.58. What is the ratio of the Unemployed and educated female labor force (% of population) of High income: OECD in 1997 to that in 2003?
Ensure brevity in your answer.  0.84. What is the ratio of the Unemployed and educated female labor force (% of population) in Argentina in 1997 to that in 2003?
Your response must be concise. 0.82. What is the ratio of the Unemployed and educated female labor force (% of population) in Belarus in 1997 to that in 2003?
Your answer should be very brief. 1. What is the ratio of the Unemployed and educated female labor force (% of population) of Denmark in 1997 to that in 2003?
Make the answer very short. 0.49. What is the ratio of the Unemployed and educated female labor force (% of population) of Argentina in 1998 to that in 1999?
Keep it short and to the point. 0.91. What is the ratio of the Unemployed and educated female labor force (% of population) in Belarus in 1998 to that in 1999?
Offer a terse response. 0.98. What is the ratio of the Unemployed and educated female labor force (% of population) of Denmark in 1998 to that in 1999?
Ensure brevity in your answer.  0.95. What is the ratio of the Unemployed and educated female labor force (% of population) in High income: OECD in 1998 to that in 2000?
Your response must be concise. 1. What is the ratio of the Unemployed and educated female labor force (% of population) of Argentina in 1998 to that in 2000?
Ensure brevity in your answer.  0.96. What is the ratio of the Unemployed and educated female labor force (% of population) in Belarus in 1998 to that in 2000?
Ensure brevity in your answer.  0.97. What is the ratio of the Unemployed and educated female labor force (% of population) of Denmark in 1998 to that in 2000?
Offer a terse response. 1.11. What is the ratio of the Unemployed and educated female labor force (% of population) of High income: OECD in 1998 to that in 2001?
Offer a very short reply. 0.93. What is the ratio of the Unemployed and educated female labor force (% of population) of Argentina in 1998 to that in 2001?
Offer a terse response. 0.84. What is the ratio of the Unemployed and educated female labor force (% of population) of Belarus in 1998 to that in 2001?
Make the answer very short. 0.99. What is the ratio of the Unemployed and educated female labor force (% of population) of Denmark in 1998 to that in 2001?
Provide a short and direct response. 0.73. What is the ratio of the Unemployed and educated female labor force (% of population) in High income: OECD in 1998 to that in 2002?
Ensure brevity in your answer.  0.83. What is the ratio of the Unemployed and educated female labor force (% of population) of Argentina in 1998 to that in 2002?
Ensure brevity in your answer.  0.74. What is the ratio of the Unemployed and educated female labor force (% of population) of Belarus in 1998 to that in 2002?
Your answer should be compact. 1.04. What is the ratio of the Unemployed and educated female labor force (% of population) of Denmark in 1998 to that in 2002?
Your answer should be very brief. 0.59. What is the ratio of the Unemployed and educated female labor force (% of population) of High income: OECD in 1998 to that in 2003?
Make the answer very short. 0.81. What is the ratio of the Unemployed and educated female labor force (% of population) of Argentina in 1998 to that in 2003?
Offer a terse response. 0.77. What is the ratio of the Unemployed and educated female labor force (% of population) of Belarus in 1998 to that in 2003?
Your response must be concise. 1.04. What is the ratio of the Unemployed and educated female labor force (% of population) in Denmark in 1998 to that in 2003?
Your response must be concise. 0.49. What is the ratio of the Unemployed and educated female labor force (% of population) in High income: OECD in 1999 to that in 2000?
Your answer should be very brief. 1.01. What is the ratio of the Unemployed and educated female labor force (% of population) in Argentina in 1999 to that in 2000?
Provide a short and direct response. 1.06. What is the ratio of the Unemployed and educated female labor force (% of population) of Belarus in 1999 to that in 2000?
Offer a very short reply. 0.99. What is the ratio of the Unemployed and educated female labor force (% of population) in Denmark in 1999 to that in 2000?
Make the answer very short. 1.16. What is the ratio of the Unemployed and educated female labor force (% of population) of High income: OECD in 1999 to that in 2001?
Give a very brief answer. 0.94. What is the ratio of the Unemployed and educated female labor force (% of population) of Argentina in 1999 to that in 2001?
Your answer should be compact. 0.92. What is the ratio of the Unemployed and educated female labor force (% of population) of Belarus in 1999 to that in 2001?
Your answer should be compact. 1.02. What is the ratio of the Unemployed and educated female labor force (% of population) of Denmark in 1999 to that in 2001?
Offer a terse response. 0.76. What is the ratio of the Unemployed and educated female labor force (% of population) in High income: OECD in 1999 to that in 2002?
Give a very brief answer. 0.84. What is the ratio of the Unemployed and educated female labor force (% of population) of Argentina in 1999 to that in 2002?
Provide a succinct answer. 0.81. What is the ratio of the Unemployed and educated female labor force (% of population) in Belarus in 1999 to that in 2002?
Keep it short and to the point. 1.06. What is the ratio of the Unemployed and educated female labor force (% of population) of Denmark in 1999 to that in 2002?
Provide a short and direct response. 0.61. What is the ratio of the Unemployed and educated female labor force (% of population) in High income: OECD in 1999 to that in 2003?
Offer a very short reply. 0.82. What is the ratio of the Unemployed and educated female labor force (% of population) in Argentina in 1999 to that in 2003?
Offer a terse response. 0.84. What is the ratio of the Unemployed and educated female labor force (% of population) of Belarus in 1999 to that in 2003?
Make the answer very short. 1.06. What is the ratio of the Unemployed and educated female labor force (% of population) of Denmark in 1999 to that in 2003?
Offer a terse response. 0.51. What is the ratio of the Unemployed and educated female labor force (% of population) of High income: OECD in 2000 to that in 2001?
Provide a succinct answer. 0.93. What is the ratio of the Unemployed and educated female labor force (% of population) in Argentina in 2000 to that in 2001?
Your answer should be very brief. 0.87. What is the ratio of the Unemployed and educated female labor force (% of population) of Belarus in 2000 to that in 2001?
Give a very brief answer. 1.02. What is the ratio of the Unemployed and educated female labor force (% of population) in Denmark in 2000 to that in 2001?
Offer a very short reply. 0.66. What is the ratio of the Unemployed and educated female labor force (% of population) of High income: OECD in 2000 to that in 2002?
Offer a very short reply. 0.83. What is the ratio of the Unemployed and educated female labor force (% of population) in Argentina in 2000 to that in 2002?
Make the answer very short. 0.77. What is the ratio of the Unemployed and educated female labor force (% of population) of Belarus in 2000 to that in 2002?
Give a very brief answer. 1.07. What is the ratio of the Unemployed and educated female labor force (% of population) in Denmark in 2000 to that in 2002?
Offer a very short reply. 0.53. What is the ratio of the Unemployed and educated female labor force (% of population) in High income: OECD in 2000 to that in 2003?
Give a very brief answer. 0.81. What is the ratio of the Unemployed and educated female labor force (% of population) in Argentina in 2000 to that in 2003?
Ensure brevity in your answer.  0.8. What is the ratio of the Unemployed and educated female labor force (% of population) in Belarus in 2000 to that in 2003?
Offer a terse response. 1.07. What is the ratio of the Unemployed and educated female labor force (% of population) of Denmark in 2000 to that in 2003?
Make the answer very short. 0.44. What is the ratio of the Unemployed and educated female labor force (% of population) in High income: OECD in 2001 to that in 2002?
Keep it short and to the point. 0.89. What is the ratio of the Unemployed and educated female labor force (% of population) of Argentina in 2001 to that in 2002?
Provide a succinct answer. 0.88. What is the ratio of the Unemployed and educated female labor force (% of population) of Belarus in 2001 to that in 2002?
Offer a very short reply. 1.05. What is the ratio of the Unemployed and educated female labor force (% of population) in Denmark in 2001 to that in 2002?
Your answer should be compact. 0.8. What is the ratio of the Unemployed and educated female labor force (% of population) in High income: OECD in 2001 to that in 2003?
Your answer should be compact. 0.87. What is the ratio of the Unemployed and educated female labor force (% of population) of Argentina in 2001 to that in 2003?
Keep it short and to the point. 0.91. What is the ratio of the Unemployed and educated female labor force (% of population) in Belarus in 2001 to that in 2003?
Offer a very short reply. 1.05. What is the ratio of the Unemployed and educated female labor force (% of population) of Denmark in 2001 to that in 2003?
Your answer should be compact. 0.67. What is the ratio of the Unemployed and educated female labor force (% of population) of High income: OECD in 2002 to that in 2003?
Provide a short and direct response. 0.98. What is the ratio of the Unemployed and educated female labor force (% of population) of Argentina in 2002 to that in 2003?
Ensure brevity in your answer.  1.04. What is the ratio of the Unemployed and educated female labor force (% of population) in Belarus in 2002 to that in 2003?
Your response must be concise. 1. What is the ratio of the Unemployed and educated female labor force (% of population) of Denmark in 2002 to that in 2003?
Offer a terse response. 0.84. What is the difference between the highest and the second highest Unemployed and educated female labor force (% of population) in High income: OECD?
Keep it short and to the point. 0.51. What is the difference between the highest and the lowest Unemployed and educated female labor force (% of population) of High income: OECD?
Your response must be concise. 4.71. What is the difference between the highest and the lowest Unemployed and educated female labor force (% of population) of Argentina?
Give a very brief answer. 6.6. 